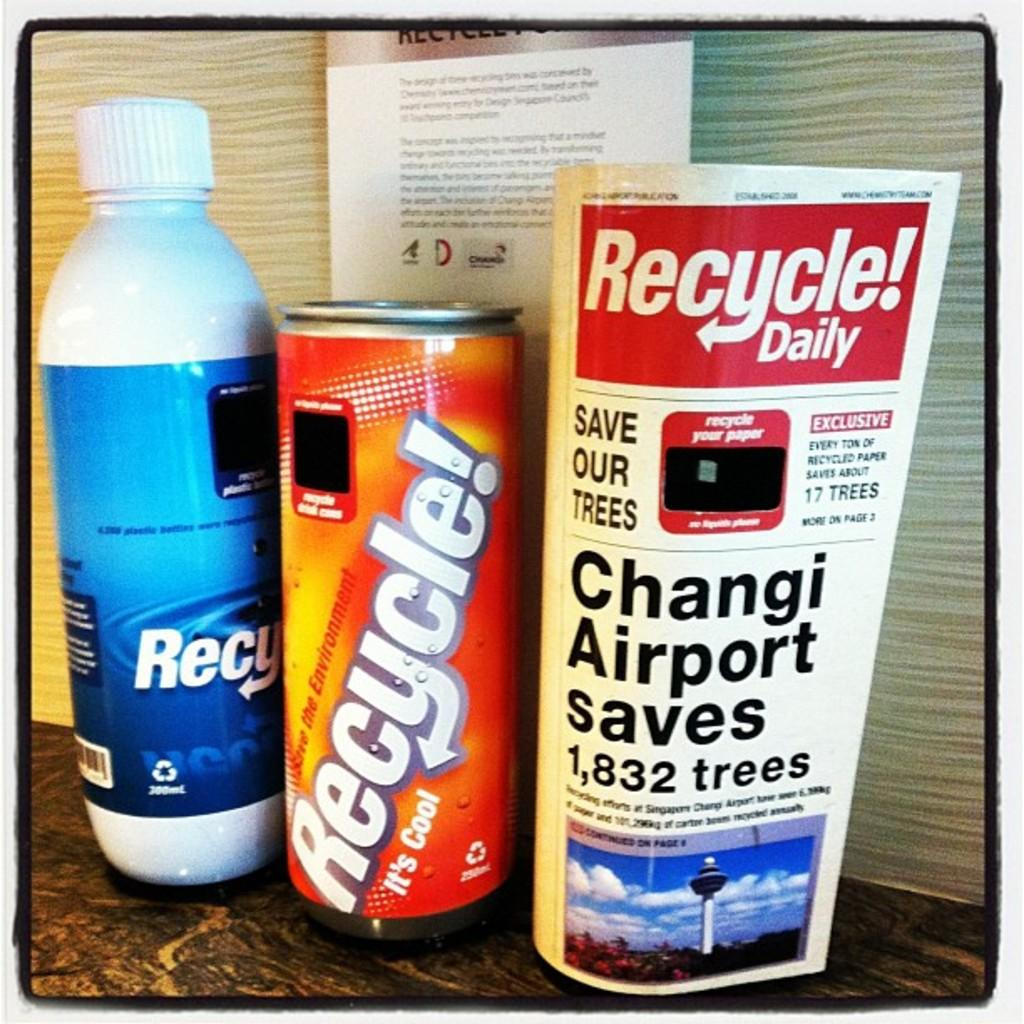<image>
Render a clear and concise summary of the photo. Three different bottles of of recycling materials and a paper with the word recycle in bold. 